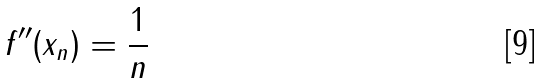Convert formula to latex. <formula><loc_0><loc_0><loc_500><loc_500>f ^ { \prime \prime } ( x _ { n } ) = \frac { 1 } { n }</formula> 